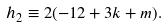<formula> <loc_0><loc_0><loc_500><loc_500>h _ { 2 } \equiv 2 ( - 1 2 + 3 k + m ) .</formula> 